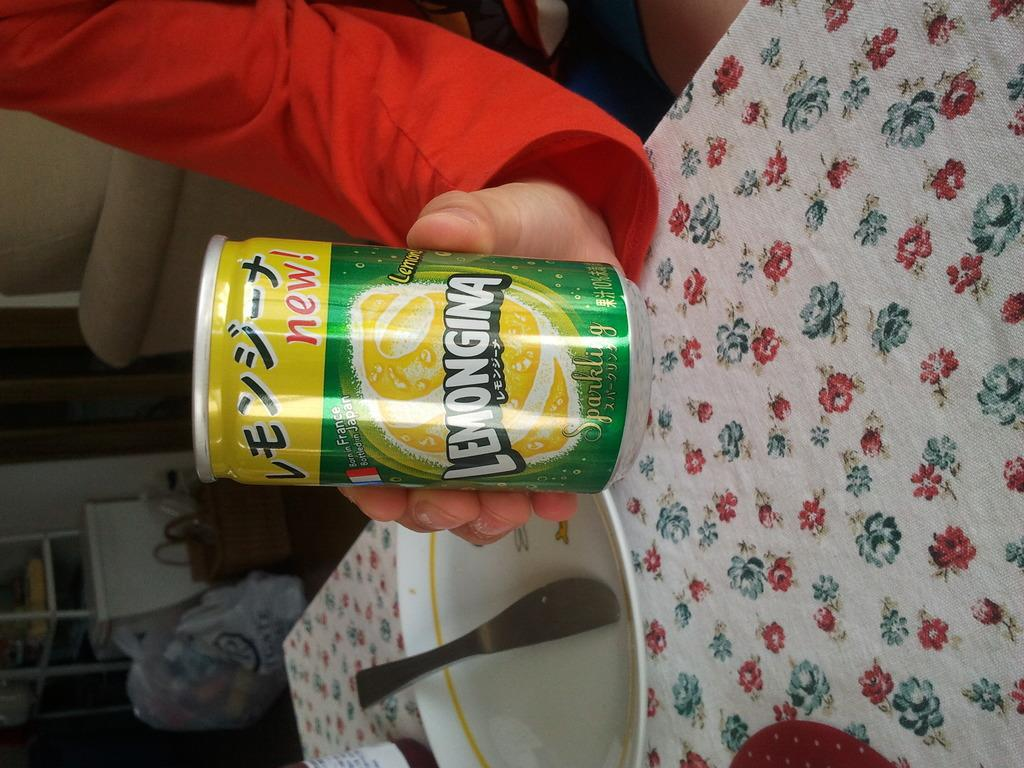Provide a one-sentence caption for the provided image. A person holds a can reading Lemongina on the label. 